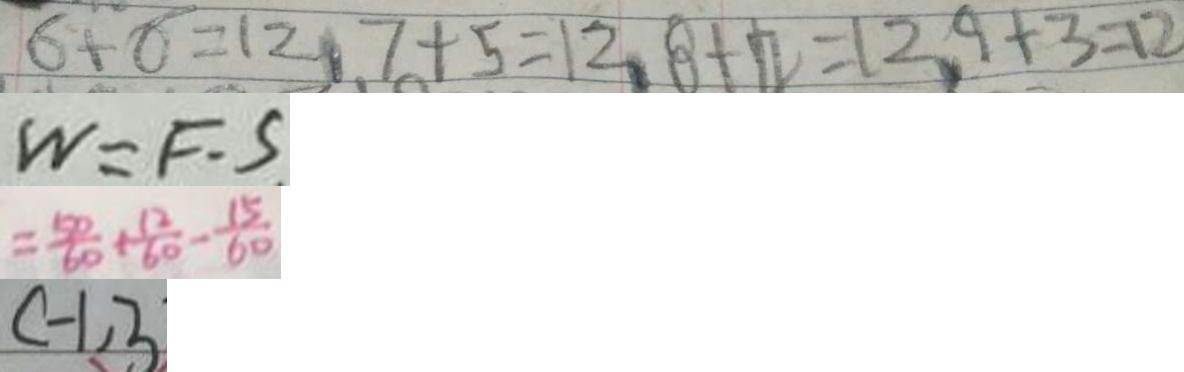Convert formula to latex. <formula><loc_0><loc_0><loc_500><loc_500>6 + 6 = 1 2 , 7 + 5 = 1 2 , 8 + 4 = 1 2 , 9 + 3 = 1 2 
 W = F \cdot S 
 = \frac { 5 0 } { 6 0 } + \frac { 1 2 } { 6 0 } - \frac { 1 5 } { 6 0 } 
 C - 1 , 3</formula> 